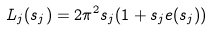<formula> <loc_0><loc_0><loc_500><loc_500>L _ { j } ( s _ { j } ) = 2 \pi ^ { 2 } s _ { j } ( 1 + s _ { j } e ( s _ { j } ) )</formula> 